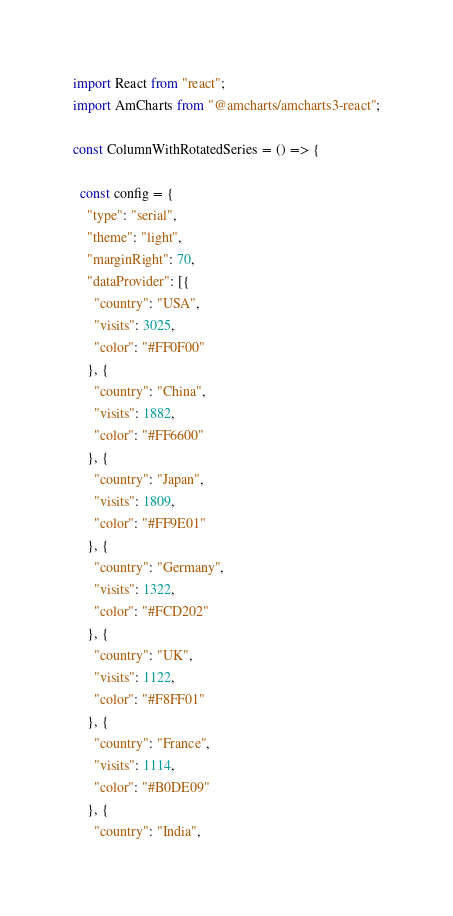Convert code to text. <code><loc_0><loc_0><loc_500><loc_500><_JavaScript_>import React from "react";
import AmCharts from "@amcharts/amcharts3-react";

const ColumnWithRotatedSeries = () => {

  const config = {
    "type": "serial",
    "theme": "light",
    "marginRight": 70,
    "dataProvider": [{
      "country": "USA",
      "visits": 3025,
      "color": "#FF0F00"
    }, {
      "country": "China",
      "visits": 1882,
      "color": "#FF6600"
    }, {
      "country": "Japan",
      "visits": 1809,
      "color": "#FF9E01"
    }, {
      "country": "Germany",
      "visits": 1322,
      "color": "#FCD202"
    }, {
      "country": "UK",
      "visits": 1122,
      "color": "#F8FF01"
    }, {
      "country": "France",
      "visits": 1114,
      "color": "#B0DE09"
    }, {
      "country": "India",</code> 